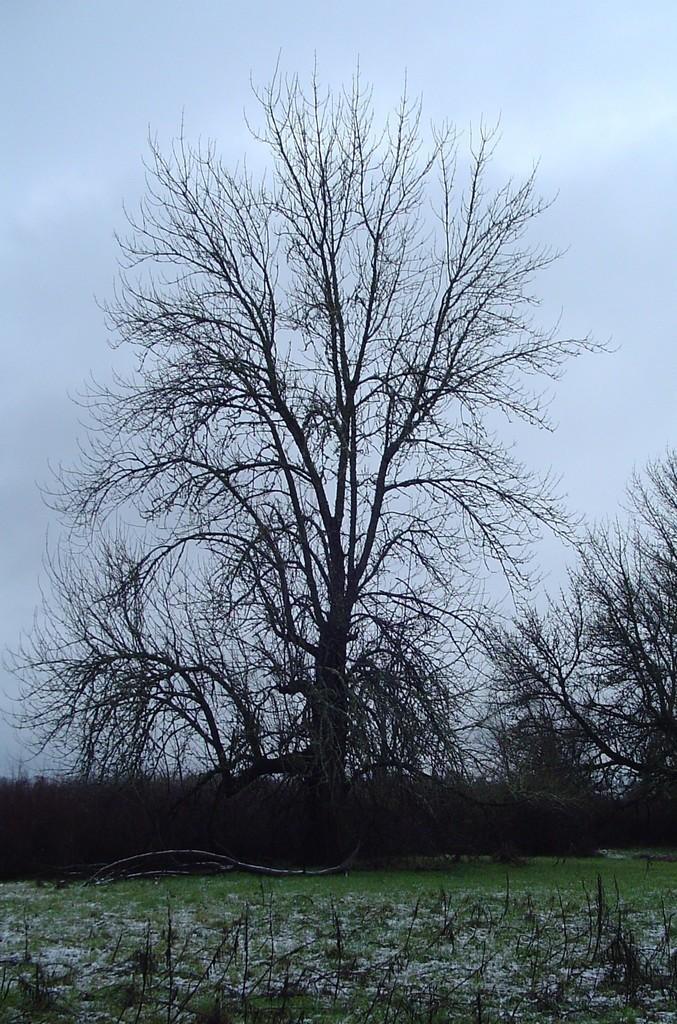Can you describe this image briefly? In this picture there are trees. At the top there is sky. At the bottom there is grass and there are plants and there is a tree branch and there might be snow. 